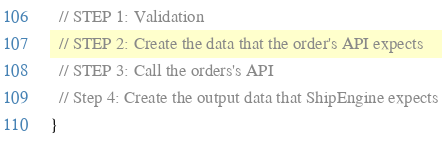Convert code to text. <code><loc_0><loc_0><loc_500><loc_500><_TypeScript_>  // STEP 1: Validation
  // STEP 2: Create the data that the order's API expects
  // STEP 3: Call the orders's API
  // Step 4: Create the output data that ShipEngine expects
}
</code> 